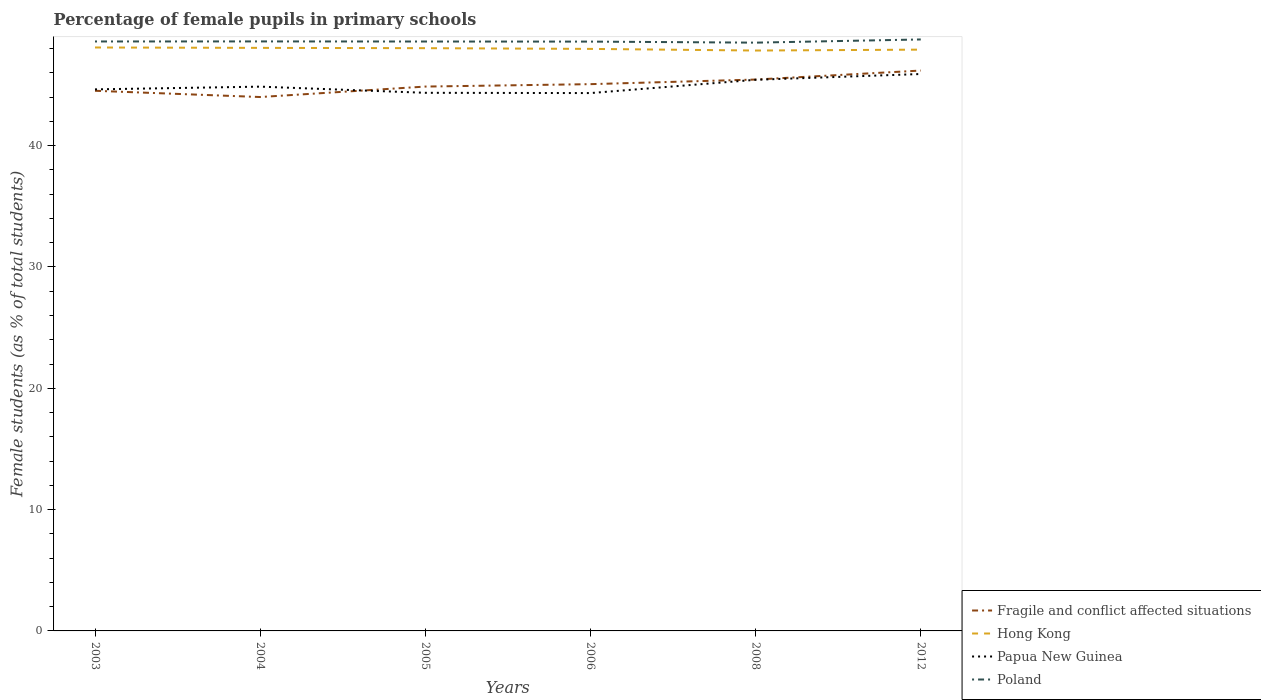Is the number of lines equal to the number of legend labels?
Ensure brevity in your answer.  Yes. Across all years, what is the maximum percentage of female pupils in primary schools in Poland?
Provide a succinct answer. 48.49. In which year was the percentage of female pupils in primary schools in Papua New Guinea maximum?
Provide a short and direct response. 2006. What is the total percentage of female pupils in primary schools in Fragile and conflict affected situations in the graph?
Your answer should be compact. -0.35. What is the difference between the highest and the second highest percentage of female pupils in primary schools in Poland?
Ensure brevity in your answer.  0.26. Is the percentage of female pupils in primary schools in Poland strictly greater than the percentage of female pupils in primary schools in Papua New Guinea over the years?
Give a very brief answer. No. How many lines are there?
Your response must be concise. 4. How many years are there in the graph?
Your response must be concise. 6. Are the values on the major ticks of Y-axis written in scientific E-notation?
Provide a short and direct response. No. Does the graph contain any zero values?
Give a very brief answer. No. Does the graph contain grids?
Give a very brief answer. No. How many legend labels are there?
Provide a succinct answer. 4. How are the legend labels stacked?
Offer a very short reply. Vertical. What is the title of the graph?
Make the answer very short. Percentage of female pupils in primary schools. What is the label or title of the Y-axis?
Provide a succinct answer. Female students (as % of total students). What is the Female students (as % of total students) in Fragile and conflict affected situations in 2003?
Offer a terse response. 44.53. What is the Female students (as % of total students) of Hong Kong in 2003?
Offer a terse response. 48.09. What is the Female students (as % of total students) in Papua New Guinea in 2003?
Give a very brief answer. 44.64. What is the Female students (as % of total students) in Poland in 2003?
Give a very brief answer. 48.59. What is the Female students (as % of total students) of Fragile and conflict affected situations in 2004?
Provide a short and direct response. 44.01. What is the Female students (as % of total students) of Hong Kong in 2004?
Keep it short and to the point. 48.06. What is the Female students (as % of total students) in Papua New Guinea in 2004?
Give a very brief answer. 44.87. What is the Female students (as % of total students) of Poland in 2004?
Give a very brief answer. 48.59. What is the Female students (as % of total students) of Fragile and conflict affected situations in 2005?
Your answer should be very brief. 44.87. What is the Female students (as % of total students) of Hong Kong in 2005?
Make the answer very short. 48.04. What is the Female students (as % of total students) of Papua New Guinea in 2005?
Your response must be concise. 44.36. What is the Female students (as % of total students) in Poland in 2005?
Your answer should be compact. 48.59. What is the Female students (as % of total students) in Fragile and conflict affected situations in 2006?
Your answer should be very brief. 45.07. What is the Female students (as % of total students) of Hong Kong in 2006?
Your answer should be very brief. 47.98. What is the Female students (as % of total students) of Papua New Guinea in 2006?
Your answer should be compact. 44.34. What is the Female students (as % of total students) of Poland in 2006?
Keep it short and to the point. 48.58. What is the Female students (as % of total students) in Fragile and conflict affected situations in 2008?
Give a very brief answer. 45.45. What is the Female students (as % of total students) of Hong Kong in 2008?
Keep it short and to the point. 47.84. What is the Female students (as % of total students) of Papua New Guinea in 2008?
Provide a short and direct response. 45.43. What is the Female students (as % of total students) of Poland in 2008?
Make the answer very short. 48.49. What is the Female students (as % of total students) of Fragile and conflict affected situations in 2012?
Provide a short and direct response. 46.19. What is the Female students (as % of total students) of Hong Kong in 2012?
Your answer should be very brief. 47.92. What is the Female students (as % of total students) in Papua New Guinea in 2012?
Offer a terse response. 45.91. What is the Female students (as % of total students) of Poland in 2012?
Your answer should be very brief. 48.76. Across all years, what is the maximum Female students (as % of total students) of Fragile and conflict affected situations?
Provide a succinct answer. 46.19. Across all years, what is the maximum Female students (as % of total students) in Hong Kong?
Your answer should be very brief. 48.09. Across all years, what is the maximum Female students (as % of total students) in Papua New Guinea?
Ensure brevity in your answer.  45.91. Across all years, what is the maximum Female students (as % of total students) in Poland?
Give a very brief answer. 48.76. Across all years, what is the minimum Female students (as % of total students) in Fragile and conflict affected situations?
Provide a short and direct response. 44.01. Across all years, what is the minimum Female students (as % of total students) of Hong Kong?
Provide a succinct answer. 47.84. Across all years, what is the minimum Female students (as % of total students) in Papua New Guinea?
Your answer should be compact. 44.34. Across all years, what is the minimum Female students (as % of total students) of Poland?
Your response must be concise. 48.49. What is the total Female students (as % of total students) of Fragile and conflict affected situations in the graph?
Your answer should be compact. 270.12. What is the total Female students (as % of total students) of Hong Kong in the graph?
Your answer should be compact. 287.93. What is the total Female students (as % of total students) in Papua New Guinea in the graph?
Your answer should be compact. 269.54. What is the total Female students (as % of total students) of Poland in the graph?
Provide a succinct answer. 291.6. What is the difference between the Female students (as % of total students) in Fragile and conflict affected situations in 2003 and that in 2004?
Offer a very short reply. 0.52. What is the difference between the Female students (as % of total students) in Hong Kong in 2003 and that in 2004?
Your response must be concise. 0.03. What is the difference between the Female students (as % of total students) of Papua New Guinea in 2003 and that in 2004?
Offer a terse response. -0.23. What is the difference between the Female students (as % of total students) of Poland in 2003 and that in 2004?
Ensure brevity in your answer.  -0. What is the difference between the Female students (as % of total students) of Fragile and conflict affected situations in 2003 and that in 2005?
Give a very brief answer. -0.35. What is the difference between the Female students (as % of total students) of Hong Kong in 2003 and that in 2005?
Your response must be concise. 0.06. What is the difference between the Female students (as % of total students) in Papua New Guinea in 2003 and that in 2005?
Offer a terse response. 0.28. What is the difference between the Female students (as % of total students) of Poland in 2003 and that in 2005?
Your answer should be compact. 0. What is the difference between the Female students (as % of total students) of Fragile and conflict affected situations in 2003 and that in 2006?
Ensure brevity in your answer.  -0.55. What is the difference between the Female students (as % of total students) of Hong Kong in 2003 and that in 2006?
Provide a short and direct response. 0.12. What is the difference between the Female students (as % of total students) of Papua New Guinea in 2003 and that in 2006?
Your answer should be very brief. 0.3. What is the difference between the Female students (as % of total students) of Poland in 2003 and that in 2006?
Provide a succinct answer. 0.01. What is the difference between the Female students (as % of total students) of Fragile and conflict affected situations in 2003 and that in 2008?
Keep it short and to the point. -0.93. What is the difference between the Female students (as % of total students) of Hong Kong in 2003 and that in 2008?
Your answer should be very brief. 0.25. What is the difference between the Female students (as % of total students) of Papua New Guinea in 2003 and that in 2008?
Provide a short and direct response. -0.79. What is the difference between the Female students (as % of total students) in Poland in 2003 and that in 2008?
Your answer should be very brief. 0.1. What is the difference between the Female students (as % of total students) of Fragile and conflict affected situations in 2003 and that in 2012?
Your answer should be compact. -1.67. What is the difference between the Female students (as % of total students) in Hong Kong in 2003 and that in 2012?
Give a very brief answer. 0.18. What is the difference between the Female students (as % of total students) in Papua New Guinea in 2003 and that in 2012?
Provide a short and direct response. -1.27. What is the difference between the Female students (as % of total students) in Poland in 2003 and that in 2012?
Make the answer very short. -0.17. What is the difference between the Female students (as % of total students) in Fragile and conflict affected situations in 2004 and that in 2005?
Give a very brief answer. -0.86. What is the difference between the Female students (as % of total students) in Hong Kong in 2004 and that in 2005?
Offer a terse response. 0.02. What is the difference between the Female students (as % of total students) in Papua New Guinea in 2004 and that in 2005?
Offer a terse response. 0.51. What is the difference between the Female students (as % of total students) in Poland in 2004 and that in 2005?
Provide a short and direct response. 0.01. What is the difference between the Female students (as % of total students) in Fragile and conflict affected situations in 2004 and that in 2006?
Provide a succinct answer. -1.06. What is the difference between the Female students (as % of total students) of Hong Kong in 2004 and that in 2006?
Keep it short and to the point. 0.08. What is the difference between the Female students (as % of total students) of Papua New Guinea in 2004 and that in 2006?
Give a very brief answer. 0.53. What is the difference between the Female students (as % of total students) in Poland in 2004 and that in 2006?
Offer a terse response. 0.02. What is the difference between the Female students (as % of total students) in Fragile and conflict affected situations in 2004 and that in 2008?
Offer a very short reply. -1.44. What is the difference between the Female students (as % of total students) of Hong Kong in 2004 and that in 2008?
Keep it short and to the point. 0.22. What is the difference between the Female students (as % of total students) of Papua New Guinea in 2004 and that in 2008?
Your answer should be very brief. -0.57. What is the difference between the Female students (as % of total students) in Poland in 2004 and that in 2008?
Your answer should be very brief. 0.1. What is the difference between the Female students (as % of total students) in Fragile and conflict affected situations in 2004 and that in 2012?
Provide a succinct answer. -2.18. What is the difference between the Female students (as % of total students) of Hong Kong in 2004 and that in 2012?
Keep it short and to the point. 0.15. What is the difference between the Female students (as % of total students) of Papua New Guinea in 2004 and that in 2012?
Make the answer very short. -1.04. What is the difference between the Female students (as % of total students) in Poland in 2004 and that in 2012?
Keep it short and to the point. -0.16. What is the difference between the Female students (as % of total students) in Fragile and conflict affected situations in 2005 and that in 2006?
Your answer should be compact. -0.2. What is the difference between the Female students (as % of total students) of Hong Kong in 2005 and that in 2006?
Keep it short and to the point. 0.06. What is the difference between the Female students (as % of total students) in Papua New Guinea in 2005 and that in 2006?
Offer a terse response. 0.02. What is the difference between the Female students (as % of total students) in Poland in 2005 and that in 2006?
Make the answer very short. 0.01. What is the difference between the Female students (as % of total students) of Fragile and conflict affected situations in 2005 and that in 2008?
Offer a terse response. -0.58. What is the difference between the Female students (as % of total students) in Hong Kong in 2005 and that in 2008?
Your answer should be compact. 0.19. What is the difference between the Female students (as % of total students) in Papua New Guinea in 2005 and that in 2008?
Your answer should be compact. -1.07. What is the difference between the Female students (as % of total students) in Poland in 2005 and that in 2008?
Your answer should be compact. 0.09. What is the difference between the Female students (as % of total students) of Fragile and conflict affected situations in 2005 and that in 2012?
Ensure brevity in your answer.  -1.32. What is the difference between the Female students (as % of total students) in Hong Kong in 2005 and that in 2012?
Your response must be concise. 0.12. What is the difference between the Female students (as % of total students) of Papua New Guinea in 2005 and that in 2012?
Provide a short and direct response. -1.55. What is the difference between the Female students (as % of total students) in Poland in 2005 and that in 2012?
Offer a very short reply. -0.17. What is the difference between the Female students (as % of total students) in Fragile and conflict affected situations in 2006 and that in 2008?
Keep it short and to the point. -0.38. What is the difference between the Female students (as % of total students) in Hong Kong in 2006 and that in 2008?
Make the answer very short. 0.13. What is the difference between the Female students (as % of total students) of Papua New Guinea in 2006 and that in 2008?
Offer a very short reply. -1.1. What is the difference between the Female students (as % of total students) of Poland in 2006 and that in 2008?
Ensure brevity in your answer.  0.09. What is the difference between the Female students (as % of total students) of Fragile and conflict affected situations in 2006 and that in 2012?
Ensure brevity in your answer.  -1.12. What is the difference between the Female students (as % of total students) in Hong Kong in 2006 and that in 2012?
Keep it short and to the point. 0.06. What is the difference between the Female students (as % of total students) of Papua New Guinea in 2006 and that in 2012?
Your answer should be compact. -1.57. What is the difference between the Female students (as % of total students) in Poland in 2006 and that in 2012?
Your answer should be compact. -0.18. What is the difference between the Female students (as % of total students) of Fragile and conflict affected situations in 2008 and that in 2012?
Keep it short and to the point. -0.74. What is the difference between the Female students (as % of total students) of Hong Kong in 2008 and that in 2012?
Your answer should be very brief. -0.07. What is the difference between the Female students (as % of total students) in Papua New Guinea in 2008 and that in 2012?
Keep it short and to the point. -0.48. What is the difference between the Female students (as % of total students) in Poland in 2008 and that in 2012?
Keep it short and to the point. -0.26. What is the difference between the Female students (as % of total students) of Fragile and conflict affected situations in 2003 and the Female students (as % of total students) of Hong Kong in 2004?
Offer a terse response. -3.54. What is the difference between the Female students (as % of total students) of Fragile and conflict affected situations in 2003 and the Female students (as % of total students) of Papua New Guinea in 2004?
Ensure brevity in your answer.  -0.34. What is the difference between the Female students (as % of total students) of Fragile and conflict affected situations in 2003 and the Female students (as % of total students) of Poland in 2004?
Offer a terse response. -4.07. What is the difference between the Female students (as % of total students) in Hong Kong in 2003 and the Female students (as % of total students) in Papua New Guinea in 2004?
Provide a succinct answer. 3.23. What is the difference between the Female students (as % of total students) of Hong Kong in 2003 and the Female students (as % of total students) of Poland in 2004?
Provide a succinct answer. -0.5. What is the difference between the Female students (as % of total students) of Papua New Guinea in 2003 and the Female students (as % of total students) of Poland in 2004?
Offer a terse response. -3.95. What is the difference between the Female students (as % of total students) of Fragile and conflict affected situations in 2003 and the Female students (as % of total students) of Hong Kong in 2005?
Give a very brief answer. -3.51. What is the difference between the Female students (as % of total students) of Fragile and conflict affected situations in 2003 and the Female students (as % of total students) of Papua New Guinea in 2005?
Your answer should be very brief. 0.17. What is the difference between the Female students (as % of total students) in Fragile and conflict affected situations in 2003 and the Female students (as % of total students) in Poland in 2005?
Keep it short and to the point. -4.06. What is the difference between the Female students (as % of total students) in Hong Kong in 2003 and the Female students (as % of total students) in Papua New Guinea in 2005?
Your answer should be compact. 3.74. What is the difference between the Female students (as % of total students) in Hong Kong in 2003 and the Female students (as % of total students) in Poland in 2005?
Provide a short and direct response. -0.49. What is the difference between the Female students (as % of total students) of Papua New Guinea in 2003 and the Female students (as % of total students) of Poland in 2005?
Offer a very short reply. -3.94. What is the difference between the Female students (as % of total students) in Fragile and conflict affected situations in 2003 and the Female students (as % of total students) in Hong Kong in 2006?
Offer a very short reply. -3.45. What is the difference between the Female students (as % of total students) in Fragile and conflict affected situations in 2003 and the Female students (as % of total students) in Papua New Guinea in 2006?
Your answer should be compact. 0.19. What is the difference between the Female students (as % of total students) in Fragile and conflict affected situations in 2003 and the Female students (as % of total students) in Poland in 2006?
Keep it short and to the point. -4.05. What is the difference between the Female students (as % of total students) in Hong Kong in 2003 and the Female students (as % of total students) in Papua New Guinea in 2006?
Ensure brevity in your answer.  3.76. What is the difference between the Female students (as % of total students) in Hong Kong in 2003 and the Female students (as % of total students) in Poland in 2006?
Your answer should be very brief. -0.49. What is the difference between the Female students (as % of total students) in Papua New Guinea in 2003 and the Female students (as % of total students) in Poland in 2006?
Your response must be concise. -3.94. What is the difference between the Female students (as % of total students) of Fragile and conflict affected situations in 2003 and the Female students (as % of total students) of Hong Kong in 2008?
Your answer should be compact. -3.32. What is the difference between the Female students (as % of total students) in Fragile and conflict affected situations in 2003 and the Female students (as % of total students) in Papua New Guinea in 2008?
Make the answer very short. -0.91. What is the difference between the Female students (as % of total students) in Fragile and conflict affected situations in 2003 and the Female students (as % of total students) in Poland in 2008?
Your response must be concise. -3.97. What is the difference between the Female students (as % of total students) in Hong Kong in 2003 and the Female students (as % of total students) in Papua New Guinea in 2008?
Ensure brevity in your answer.  2.66. What is the difference between the Female students (as % of total students) in Hong Kong in 2003 and the Female students (as % of total students) in Poland in 2008?
Your answer should be compact. -0.4. What is the difference between the Female students (as % of total students) of Papua New Guinea in 2003 and the Female students (as % of total students) of Poland in 2008?
Provide a succinct answer. -3.85. What is the difference between the Female students (as % of total students) of Fragile and conflict affected situations in 2003 and the Female students (as % of total students) of Hong Kong in 2012?
Your answer should be compact. -3.39. What is the difference between the Female students (as % of total students) in Fragile and conflict affected situations in 2003 and the Female students (as % of total students) in Papua New Guinea in 2012?
Make the answer very short. -1.38. What is the difference between the Female students (as % of total students) in Fragile and conflict affected situations in 2003 and the Female students (as % of total students) in Poland in 2012?
Make the answer very short. -4.23. What is the difference between the Female students (as % of total students) in Hong Kong in 2003 and the Female students (as % of total students) in Papua New Guinea in 2012?
Ensure brevity in your answer.  2.19. What is the difference between the Female students (as % of total students) of Hong Kong in 2003 and the Female students (as % of total students) of Poland in 2012?
Provide a short and direct response. -0.66. What is the difference between the Female students (as % of total students) in Papua New Guinea in 2003 and the Female students (as % of total students) in Poland in 2012?
Make the answer very short. -4.12. What is the difference between the Female students (as % of total students) of Fragile and conflict affected situations in 2004 and the Female students (as % of total students) of Hong Kong in 2005?
Provide a succinct answer. -4.03. What is the difference between the Female students (as % of total students) of Fragile and conflict affected situations in 2004 and the Female students (as % of total students) of Papua New Guinea in 2005?
Offer a very short reply. -0.35. What is the difference between the Female students (as % of total students) in Fragile and conflict affected situations in 2004 and the Female students (as % of total students) in Poland in 2005?
Give a very brief answer. -4.58. What is the difference between the Female students (as % of total students) of Hong Kong in 2004 and the Female students (as % of total students) of Papua New Guinea in 2005?
Keep it short and to the point. 3.7. What is the difference between the Female students (as % of total students) of Hong Kong in 2004 and the Female students (as % of total students) of Poland in 2005?
Provide a short and direct response. -0.52. What is the difference between the Female students (as % of total students) of Papua New Guinea in 2004 and the Female students (as % of total students) of Poland in 2005?
Provide a short and direct response. -3.72. What is the difference between the Female students (as % of total students) in Fragile and conflict affected situations in 2004 and the Female students (as % of total students) in Hong Kong in 2006?
Your answer should be very brief. -3.97. What is the difference between the Female students (as % of total students) in Fragile and conflict affected situations in 2004 and the Female students (as % of total students) in Papua New Guinea in 2006?
Your answer should be very brief. -0.33. What is the difference between the Female students (as % of total students) in Fragile and conflict affected situations in 2004 and the Female students (as % of total students) in Poland in 2006?
Make the answer very short. -4.57. What is the difference between the Female students (as % of total students) of Hong Kong in 2004 and the Female students (as % of total students) of Papua New Guinea in 2006?
Offer a very short reply. 3.73. What is the difference between the Female students (as % of total students) of Hong Kong in 2004 and the Female students (as % of total students) of Poland in 2006?
Ensure brevity in your answer.  -0.52. What is the difference between the Female students (as % of total students) of Papua New Guinea in 2004 and the Female students (as % of total students) of Poland in 2006?
Make the answer very short. -3.71. What is the difference between the Female students (as % of total students) of Fragile and conflict affected situations in 2004 and the Female students (as % of total students) of Hong Kong in 2008?
Provide a succinct answer. -3.83. What is the difference between the Female students (as % of total students) in Fragile and conflict affected situations in 2004 and the Female students (as % of total students) in Papua New Guinea in 2008?
Provide a succinct answer. -1.42. What is the difference between the Female students (as % of total students) in Fragile and conflict affected situations in 2004 and the Female students (as % of total students) in Poland in 2008?
Offer a very short reply. -4.48. What is the difference between the Female students (as % of total students) of Hong Kong in 2004 and the Female students (as % of total students) of Papua New Guinea in 2008?
Offer a very short reply. 2.63. What is the difference between the Female students (as % of total students) in Hong Kong in 2004 and the Female students (as % of total students) in Poland in 2008?
Ensure brevity in your answer.  -0.43. What is the difference between the Female students (as % of total students) in Papua New Guinea in 2004 and the Female students (as % of total students) in Poland in 2008?
Your response must be concise. -3.63. What is the difference between the Female students (as % of total students) of Fragile and conflict affected situations in 2004 and the Female students (as % of total students) of Hong Kong in 2012?
Your answer should be compact. -3.91. What is the difference between the Female students (as % of total students) of Fragile and conflict affected situations in 2004 and the Female students (as % of total students) of Papua New Guinea in 2012?
Give a very brief answer. -1.9. What is the difference between the Female students (as % of total students) of Fragile and conflict affected situations in 2004 and the Female students (as % of total students) of Poland in 2012?
Ensure brevity in your answer.  -4.75. What is the difference between the Female students (as % of total students) of Hong Kong in 2004 and the Female students (as % of total students) of Papua New Guinea in 2012?
Keep it short and to the point. 2.15. What is the difference between the Female students (as % of total students) of Hong Kong in 2004 and the Female students (as % of total students) of Poland in 2012?
Ensure brevity in your answer.  -0.69. What is the difference between the Female students (as % of total students) of Papua New Guinea in 2004 and the Female students (as % of total students) of Poland in 2012?
Your answer should be compact. -3.89. What is the difference between the Female students (as % of total students) in Fragile and conflict affected situations in 2005 and the Female students (as % of total students) in Hong Kong in 2006?
Offer a terse response. -3.11. What is the difference between the Female students (as % of total students) in Fragile and conflict affected situations in 2005 and the Female students (as % of total students) in Papua New Guinea in 2006?
Provide a succinct answer. 0.54. What is the difference between the Female students (as % of total students) in Fragile and conflict affected situations in 2005 and the Female students (as % of total students) in Poland in 2006?
Your answer should be very brief. -3.71. What is the difference between the Female students (as % of total students) in Hong Kong in 2005 and the Female students (as % of total students) in Papua New Guinea in 2006?
Give a very brief answer. 3.7. What is the difference between the Female students (as % of total students) in Hong Kong in 2005 and the Female students (as % of total students) in Poland in 2006?
Provide a succinct answer. -0.54. What is the difference between the Female students (as % of total students) of Papua New Guinea in 2005 and the Female students (as % of total students) of Poland in 2006?
Offer a very short reply. -4.22. What is the difference between the Female students (as % of total students) of Fragile and conflict affected situations in 2005 and the Female students (as % of total students) of Hong Kong in 2008?
Provide a succinct answer. -2.97. What is the difference between the Female students (as % of total students) of Fragile and conflict affected situations in 2005 and the Female students (as % of total students) of Papua New Guinea in 2008?
Your answer should be very brief. -0.56. What is the difference between the Female students (as % of total students) in Fragile and conflict affected situations in 2005 and the Female students (as % of total students) in Poland in 2008?
Your answer should be compact. -3.62. What is the difference between the Female students (as % of total students) in Hong Kong in 2005 and the Female students (as % of total students) in Papua New Guinea in 2008?
Provide a short and direct response. 2.61. What is the difference between the Female students (as % of total students) in Hong Kong in 2005 and the Female students (as % of total students) in Poland in 2008?
Offer a very short reply. -0.46. What is the difference between the Female students (as % of total students) of Papua New Guinea in 2005 and the Female students (as % of total students) of Poland in 2008?
Make the answer very short. -4.13. What is the difference between the Female students (as % of total students) of Fragile and conflict affected situations in 2005 and the Female students (as % of total students) of Hong Kong in 2012?
Provide a short and direct response. -3.04. What is the difference between the Female students (as % of total students) in Fragile and conflict affected situations in 2005 and the Female students (as % of total students) in Papua New Guinea in 2012?
Your answer should be compact. -1.03. What is the difference between the Female students (as % of total students) of Fragile and conflict affected situations in 2005 and the Female students (as % of total students) of Poland in 2012?
Your answer should be very brief. -3.88. What is the difference between the Female students (as % of total students) of Hong Kong in 2005 and the Female students (as % of total students) of Papua New Guinea in 2012?
Offer a terse response. 2.13. What is the difference between the Female students (as % of total students) of Hong Kong in 2005 and the Female students (as % of total students) of Poland in 2012?
Your response must be concise. -0.72. What is the difference between the Female students (as % of total students) in Papua New Guinea in 2005 and the Female students (as % of total students) in Poland in 2012?
Give a very brief answer. -4.4. What is the difference between the Female students (as % of total students) of Fragile and conflict affected situations in 2006 and the Female students (as % of total students) of Hong Kong in 2008?
Provide a short and direct response. -2.77. What is the difference between the Female students (as % of total students) in Fragile and conflict affected situations in 2006 and the Female students (as % of total students) in Papua New Guinea in 2008?
Give a very brief answer. -0.36. What is the difference between the Female students (as % of total students) in Fragile and conflict affected situations in 2006 and the Female students (as % of total students) in Poland in 2008?
Offer a very short reply. -3.42. What is the difference between the Female students (as % of total students) in Hong Kong in 2006 and the Female students (as % of total students) in Papua New Guinea in 2008?
Make the answer very short. 2.55. What is the difference between the Female students (as % of total students) in Hong Kong in 2006 and the Female students (as % of total students) in Poland in 2008?
Make the answer very short. -0.52. What is the difference between the Female students (as % of total students) of Papua New Guinea in 2006 and the Female students (as % of total students) of Poland in 2008?
Give a very brief answer. -4.16. What is the difference between the Female students (as % of total students) in Fragile and conflict affected situations in 2006 and the Female students (as % of total students) in Hong Kong in 2012?
Make the answer very short. -2.84. What is the difference between the Female students (as % of total students) in Fragile and conflict affected situations in 2006 and the Female students (as % of total students) in Papua New Guinea in 2012?
Provide a short and direct response. -0.84. What is the difference between the Female students (as % of total students) in Fragile and conflict affected situations in 2006 and the Female students (as % of total students) in Poland in 2012?
Your answer should be very brief. -3.68. What is the difference between the Female students (as % of total students) of Hong Kong in 2006 and the Female students (as % of total students) of Papua New Guinea in 2012?
Provide a succinct answer. 2.07. What is the difference between the Female students (as % of total students) of Hong Kong in 2006 and the Female students (as % of total students) of Poland in 2012?
Offer a very short reply. -0.78. What is the difference between the Female students (as % of total students) of Papua New Guinea in 2006 and the Female students (as % of total students) of Poland in 2012?
Ensure brevity in your answer.  -4.42. What is the difference between the Female students (as % of total students) of Fragile and conflict affected situations in 2008 and the Female students (as % of total students) of Hong Kong in 2012?
Provide a succinct answer. -2.47. What is the difference between the Female students (as % of total students) in Fragile and conflict affected situations in 2008 and the Female students (as % of total students) in Papua New Guinea in 2012?
Ensure brevity in your answer.  -0.46. What is the difference between the Female students (as % of total students) of Fragile and conflict affected situations in 2008 and the Female students (as % of total students) of Poland in 2012?
Your answer should be very brief. -3.31. What is the difference between the Female students (as % of total students) of Hong Kong in 2008 and the Female students (as % of total students) of Papua New Guinea in 2012?
Your response must be concise. 1.94. What is the difference between the Female students (as % of total students) of Hong Kong in 2008 and the Female students (as % of total students) of Poland in 2012?
Your answer should be compact. -0.91. What is the difference between the Female students (as % of total students) of Papua New Guinea in 2008 and the Female students (as % of total students) of Poland in 2012?
Make the answer very short. -3.32. What is the average Female students (as % of total students) of Fragile and conflict affected situations per year?
Your response must be concise. 45.02. What is the average Female students (as % of total students) of Hong Kong per year?
Your answer should be very brief. 47.99. What is the average Female students (as % of total students) in Papua New Guinea per year?
Offer a very short reply. 44.92. What is the average Female students (as % of total students) in Poland per year?
Offer a terse response. 48.6. In the year 2003, what is the difference between the Female students (as % of total students) of Fragile and conflict affected situations and Female students (as % of total students) of Hong Kong?
Make the answer very short. -3.57. In the year 2003, what is the difference between the Female students (as % of total students) of Fragile and conflict affected situations and Female students (as % of total students) of Papua New Guinea?
Keep it short and to the point. -0.12. In the year 2003, what is the difference between the Female students (as % of total students) in Fragile and conflict affected situations and Female students (as % of total students) in Poland?
Offer a very short reply. -4.06. In the year 2003, what is the difference between the Female students (as % of total students) of Hong Kong and Female students (as % of total students) of Papua New Guinea?
Your answer should be compact. 3.45. In the year 2003, what is the difference between the Female students (as % of total students) in Hong Kong and Female students (as % of total students) in Poland?
Provide a short and direct response. -0.5. In the year 2003, what is the difference between the Female students (as % of total students) in Papua New Guinea and Female students (as % of total students) in Poland?
Provide a short and direct response. -3.95. In the year 2004, what is the difference between the Female students (as % of total students) in Fragile and conflict affected situations and Female students (as % of total students) in Hong Kong?
Give a very brief answer. -4.05. In the year 2004, what is the difference between the Female students (as % of total students) in Fragile and conflict affected situations and Female students (as % of total students) in Papua New Guinea?
Ensure brevity in your answer.  -0.86. In the year 2004, what is the difference between the Female students (as % of total students) of Fragile and conflict affected situations and Female students (as % of total students) of Poland?
Provide a short and direct response. -4.58. In the year 2004, what is the difference between the Female students (as % of total students) in Hong Kong and Female students (as % of total students) in Papua New Guinea?
Provide a succinct answer. 3.2. In the year 2004, what is the difference between the Female students (as % of total students) of Hong Kong and Female students (as % of total students) of Poland?
Your answer should be very brief. -0.53. In the year 2004, what is the difference between the Female students (as % of total students) of Papua New Guinea and Female students (as % of total students) of Poland?
Your answer should be compact. -3.73. In the year 2005, what is the difference between the Female students (as % of total students) of Fragile and conflict affected situations and Female students (as % of total students) of Hong Kong?
Provide a short and direct response. -3.16. In the year 2005, what is the difference between the Female students (as % of total students) in Fragile and conflict affected situations and Female students (as % of total students) in Papua New Guinea?
Your answer should be compact. 0.51. In the year 2005, what is the difference between the Female students (as % of total students) of Fragile and conflict affected situations and Female students (as % of total students) of Poland?
Your response must be concise. -3.71. In the year 2005, what is the difference between the Female students (as % of total students) of Hong Kong and Female students (as % of total students) of Papua New Guinea?
Your answer should be very brief. 3.68. In the year 2005, what is the difference between the Female students (as % of total students) of Hong Kong and Female students (as % of total students) of Poland?
Provide a succinct answer. -0.55. In the year 2005, what is the difference between the Female students (as % of total students) in Papua New Guinea and Female students (as % of total students) in Poland?
Provide a succinct answer. -4.23. In the year 2006, what is the difference between the Female students (as % of total students) in Fragile and conflict affected situations and Female students (as % of total students) in Hong Kong?
Make the answer very short. -2.91. In the year 2006, what is the difference between the Female students (as % of total students) in Fragile and conflict affected situations and Female students (as % of total students) in Papua New Guinea?
Provide a short and direct response. 0.74. In the year 2006, what is the difference between the Female students (as % of total students) of Fragile and conflict affected situations and Female students (as % of total students) of Poland?
Your answer should be compact. -3.51. In the year 2006, what is the difference between the Female students (as % of total students) of Hong Kong and Female students (as % of total students) of Papua New Guinea?
Give a very brief answer. 3.64. In the year 2006, what is the difference between the Female students (as % of total students) in Hong Kong and Female students (as % of total students) in Poland?
Offer a terse response. -0.6. In the year 2006, what is the difference between the Female students (as % of total students) in Papua New Guinea and Female students (as % of total students) in Poland?
Keep it short and to the point. -4.24. In the year 2008, what is the difference between the Female students (as % of total students) in Fragile and conflict affected situations and Female students (as % of total students) in Hong Kong?
Offer a very short reply. -2.39. In the year 2008, what is the difference between the Female students (as % of total students) of Fragile and conflict affected situations and Female students (as % of total students) of Papua New Guinea?
Your response must be concise. 0.02. In the year 2008, what is the difference between the Female students (as % of total students) in Fragile and conflict affected situations and Female students (as % of total students) in Poland?
Your response must be concise. -3.04. In the year 2008, what is the difference between the Female students (as % of total students) in Hong Kong and Female students (as % of total students) in Papua New Guinea?
Keep it short and to the point. 2.41. In the year 2008, what is the difference between the Female students (as % of total students) in Hong Kong and Female students (as % of total students) in Poland?
Offer a terse response. -0.65. In the year 2008, what is the difference between the Female students (as % of total students) of Papua New Guinea and Female students (as % of total students) of Poland?
Give a very brief answer. -3.06. In the year 2012, what is the difference between the Female students (as % of total students) in Fragile and conflict affected situations and Female students (as % of total students) in Hong Kong?
Your answer should be very brief. -1.72. In the year 2012, what is the difference between the Female students (as % of total students) in Fragile and conflict affected situations and Female students (as % of total students) in Papua New Guinea?
Your answer should be compact. 0.29. In the year 2012, what is the difference between the Female students (as % of total students) of Fragile and conflict affected situations and Female students (as % of total students) of Poland?
Offer a terse response. -2.56. In the year 2012, what is the difference between the Female students (as % of total students) in Hong Kong and Female students (as % of total students) in Papua New Guinea?
Give a very brief answer. 2.01. In the year 2012, what is the difference between the Female students (as % of total students) of Hong Kong and Female students (as % of total students) of Poland?
Your answer should be compact. -0.84. In the year 2012, what is the difference between the Female students (as % of total students) in Papua New Guinea and Female students (as % of total students) in Poland?
Your answer should be compact. -2.85. What is the ratio of the Female students (as % of total students) in Fragile and conflict affected situations in 2003 to that in 2004?
Make the answer very short. 1.01. What is the ratio of the Female students (as % of total students) in Papua New Guinea in 2003 to that in 2004?
Your response must be concise. 0.99. What is the ratio of the Female students (as % of total students) in Poland in 2003 to that in 2004?
Your response must be concise. 1. What is the ratio of the Female students (as % of total students) of Hong Kong in 2003 to that in 2005?
Your response must be concise. 1. What is the ratio of the Female students (as % of total students) of Papua New Guinea in 2003 to that in 2005?
Give a very brief answer. 1.01. What is the ratio of the Female students (as % of total students) in Poland in 2003 to that in 2005?
Provide a succinct answer. 1. What is the ratio of the Female students (as % of total students) in Fragile and conflict affected situations in 2003 to that in 2006?
Your answer should be very brief. 0.99. What is the ratio of the Female students (as % of total students) of Papua New Guinea in 2003 to that in 2006?
Offer a very short reply. 1.01. What is the ratio of the Female students (as % of total students) of Fragile and conflict affected situations in 2003 to that in 2008?
Give a very brief answer. 0.98. What is the ratio of the Female students (as % of total students) in Papua New Guinea in 2003 to that in 2008?
Your response must be concise. 0.98. What is the ratio of the Female students (as % of total students) of Fragile and conflict affected situations in 2003 to that in 2012?
Give a very brief answer. 0.96. What is the ratio of the Female students (as % of total students) in Hong Kong in 2003 to that in 2012?
Give a very brief answer. 1. What is the ratio of the Female students (as % of total students) in Papua New Guinea in 2003 to that in 2012?
Give a very brief answer. 0.97. What is the ratio of the Female students (as % of total students) in Poland in 2003 to that in 2012?
Give a very brief answer. 1. What is the ratio of the Female students (as % of total students) of Fragile and conflict affected situations in 2004 to that in 2005?
Your answer should be very brief. 0.98. What is the ratio of the Female students (as % of total students) in Papua New Guinea in 2004 to that in 2005?
Make the answer very short. 1.01. What is the ratio of the Female students (as % of total students) of Poland in 2004 to that in 2005?
Ensure brevity in your answer.  1. What is the ratio of the Female students (as % of total students) of Fragile and conflict affected situations in 2004 to that in 2006?
Give a very brief answer. 0.98. What is the ratio of the Female students (as % of total students) of Fragile and conflict affected situations in 2004 to that in 2008?
Offer a terse response. 0.97. What is the ratio of the Female students (as % of total students) in Hong Kong in 2004 to that in 2008?
Your response must be concise. 1. What is the ratio of the Female students (as % of total students) of Papua New Guinea in 2004 to that in 2008?
Provide a succinct answer. 0.99. What is the ratio of the Female students (as % of total students) in Poland in 2004 to that in 2008?
Ensure brevity in your answer.  1. What is the ratio of the Female students (as % of total students) of Fragile and conflict affected situations in 2004 to that in 2012?
Give a very brief answer. 0.95. What is the ratio of the Female students (as % of total students) of Hong Kong in 2004 to that in 2012?
Provide a short and direct response. 1. What is the ratio of the Female students (as % of total students) of Papua New Guinea in 2004 to that in 2012?
Ensure brevity in your answer.  0.98. What is the ratio of the Female students (as % of total students) of Papua New Guinea in 2005 to that in 2006?
Offer a very short reply. 1. What is the ratio of the Female students (as % of total students) in Poland in 2005 to that in 2006?
Provide a succinct answer. 1. What is the ratio of the Female students (as % of total students) in Fragile and conflict affected situations in 2005 to that in 2008?
Provide a short and direct response. 0.99. What is the ratio of the Female students (as % of total students) in Papua New Guinea in 2005 to that in 2008?
Make the answer very short. 0.98. What is the ratio of the Female students (as % of total students) in Poland in 2005 to that in 2008?
Your answer should be very brief. 1. What is the ratio of the Female students (as % of total students) of Fragile and conflict affected situations in 2005 to that in 2012?
Your answer should be compact. 0.97. What is the ratio of the Female students (as % of total students) in Hong Kong in 2005 to that in 2012?
Ensure brevity in your answer.  1. What is the ratio of the Female students (as % of total students) in Papua New Guinea in 2005 to that in 2012?
Offer a very short reply. 0.97. What is the ratio of the Female students (as % of total students) in Fragile and conflict affected situations in 2006 to that in 2008?
Provide a succinct answer. 0.99. What is the ratio of the Female students (as % of total students) of Hong Kong in 2006 to that in 2008?
Your answer should be compact. 1. What is the ratio of the Female students (as % of total students) in Papua New Guinea in 2006 to that in 2008?
Provide a succinct answer. 0.98. What is the ratio of the Female students (as % of total students) of Fragile and conflict affected situations in 2006 to that in 2012?
Your response must be concise. 0.98. What is the ratio of the Female students (as % of total students) of Hong Kong in 2006 to that in 2012?
Give a very brief answer. 1. What is the ratio of the Female students (as % of total students) in Papua New Guinea in 2006 to that in 2012?
Offer a terse response. 0.97. What is the ratio of the Female students (as % of total students) of Fragile and conflict affected situations in 2008 to that in 2012?
Your response must be concise. 0.98. What is the difference between the highest and the second highest Female students (as % of total students) of Fragile and conflict affected situations?
Provide a succinct answer. 0.74. What is the difference between the highest and the second highest Female students (as % of total students) of Hong Kong?
Give a very brief answer. 0.03. What is the difference between the highest and the second highest Female students (as % of total students) of Papua New Guinea?
Your answer should be compact. 0.48. What is the difference between the highest and the second highest Female students (as % of total students) of Poland?
Provide a short and direct response. 0.16. What is the difference between the highest and the lowest Female students (as % of total students) in Fragile and conflict affected situations?
Your answer should be compact. 2.18. What is the difference between the highest and the lowest Female students (as % of total students) of Hong Kong?
Ensure brevity in your answer.  0.25. What is the difference between the highest and the lowest Female students (as % of total students) of Papua New Guinea?
Provide a succinct answer. 1.57. What is the difference between the highest and the lowest Female students (as % of total students) of Poland?
Provide a succinct answer. 0.26. 